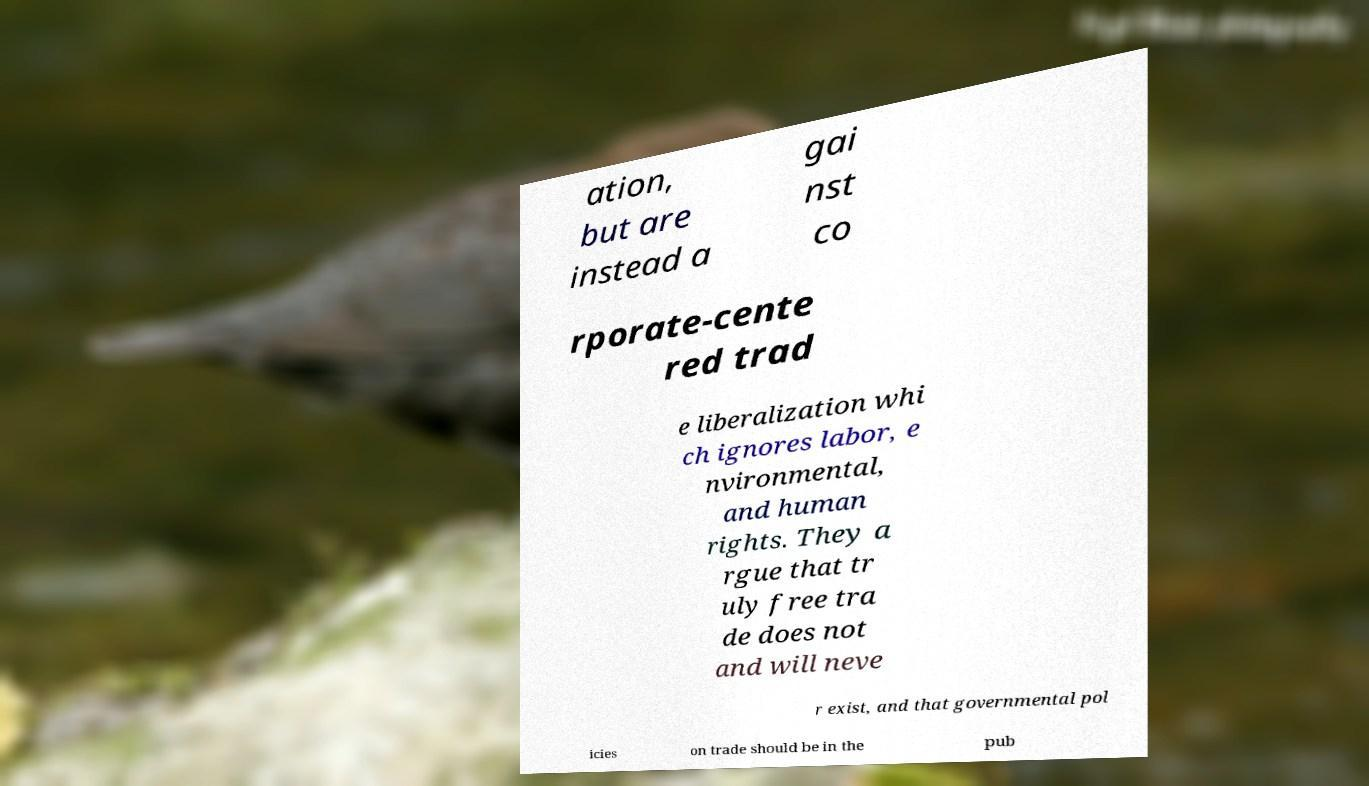What messages or text are displayed in this image? I need them in a readable, typed format. ation, but are instead a gai nst co rporate-cente red trad e liberalization whi ch ignores labor, e nvironmental, and human rights. They a rgue that tr uly free tra de does not and will neve r exist, and that governmental pol icies on trade should be in the pub 